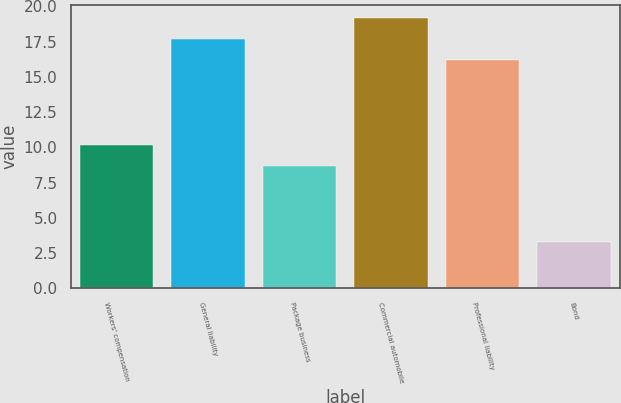Convert chart to OTSL. <chart><loc_0><loc_0><loc_500><loc_500><bar_chart><fcel>Workers' compensation<fcel>General liability<fcel>Package business<fcel>Commercial automobile<fcel>Professional liability<fcel>Bond<nl><fcel>10.18<fcel>17.68<fcel>8.7<fcel>19.16<fcel>16.2<fcel>3.3<nl></chart> 